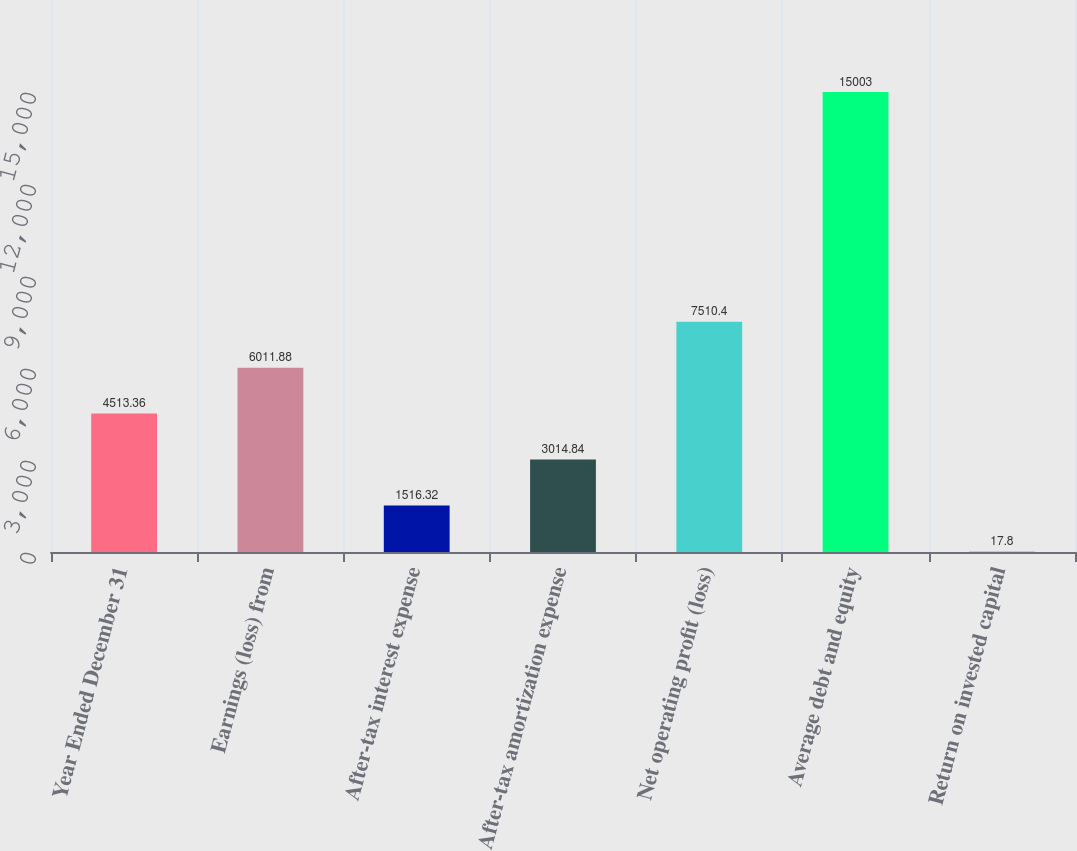Convert chart to OTSL. <chart><loc_0><loc_0><loc_500><loc_500><bar_chart><fcel>Year Ended December 31<fcel>Earnings (loss) from<fcel>After-tax interest expense<fcel>After-tax amortization expense<fcel>Net operating profit (loss)<fcel>Average debt and equity<fcel>Return on invested capital<nl><fcel>4513.36<fcel>6011.88<fcel>1516.32<fcel>3014.84<fcel>7510.4<fcel>15003<fcel>17.8<nl></chart> 